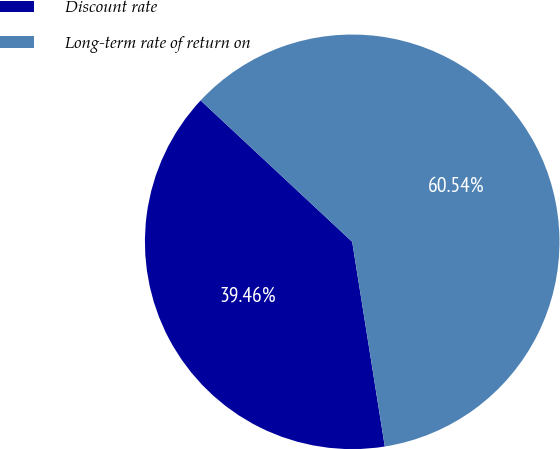Convert chart. <chart><loc_0><loc_0><loc_500><loc_500><pie_chart><fcel>Discount rate<fcel>Long-term rate of return on<nl><fcel>39.46%<fcel>60.54%<nl></chart> 